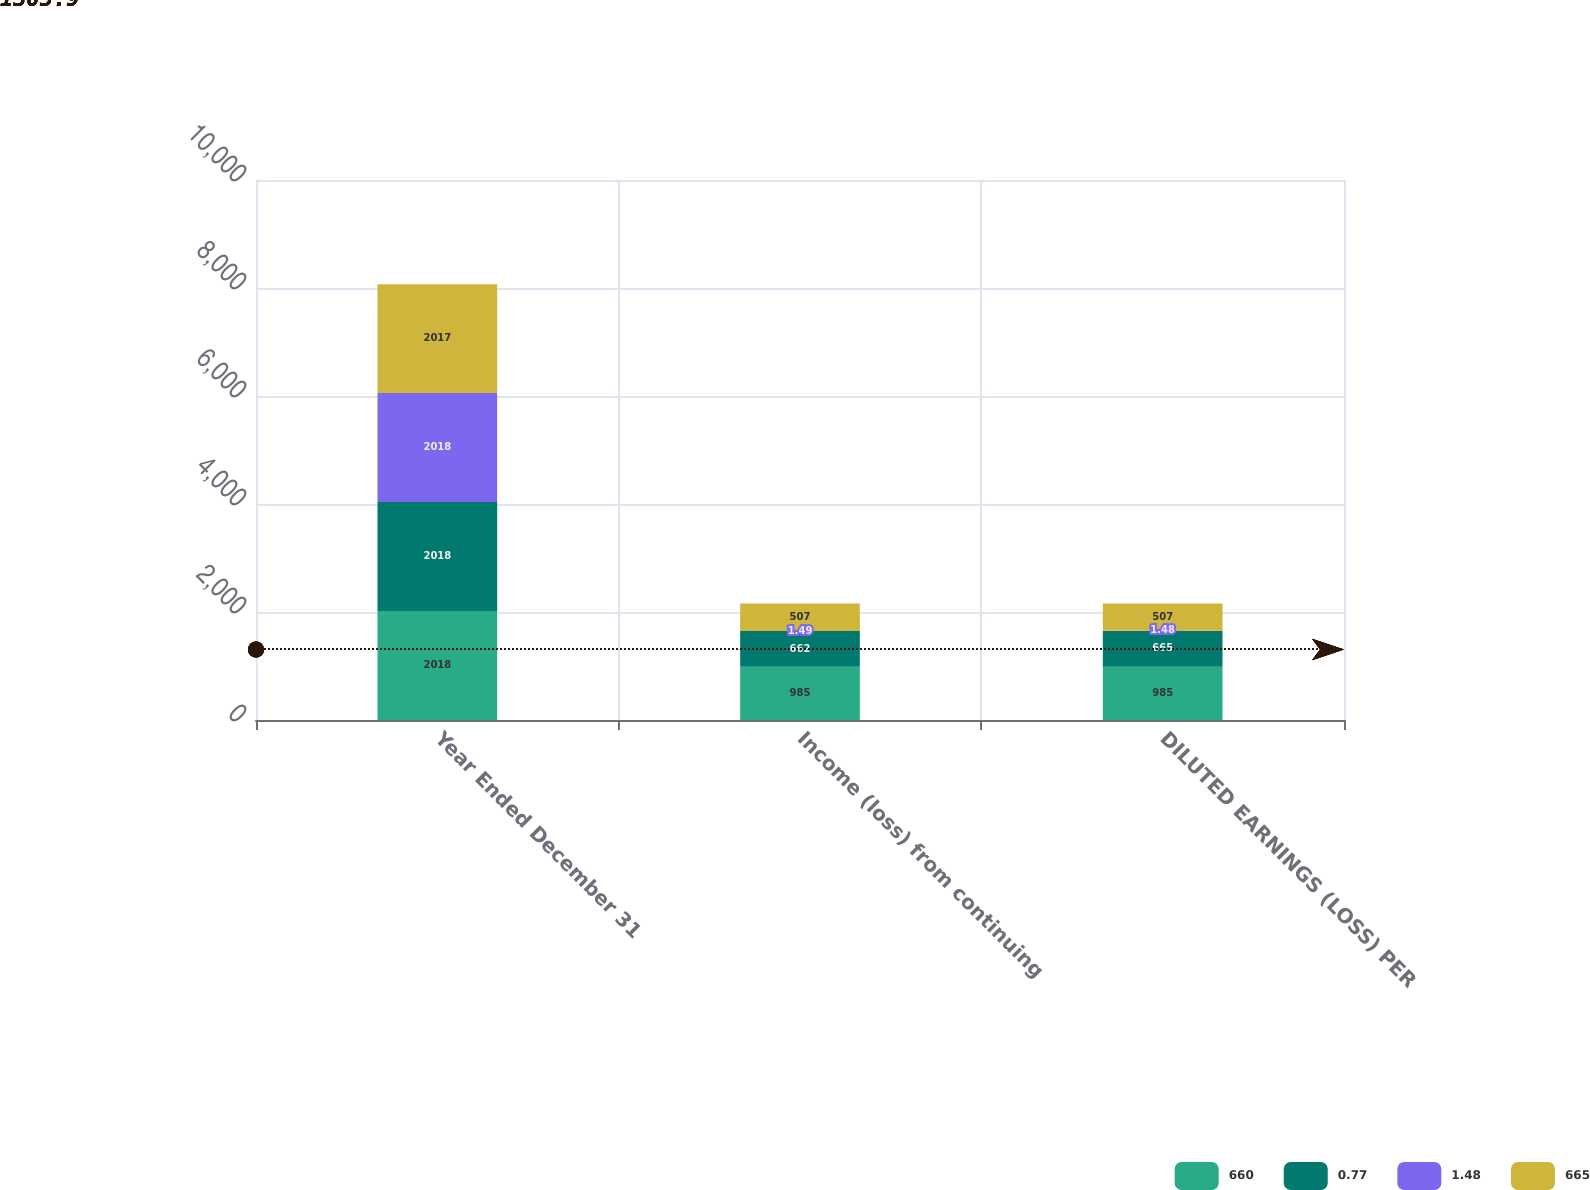Convert chart. <chart><loc_0><loc_0><loc_500><loc_500><stacked_bar_chart><ecel><fcel>Year Ended December 31<fcel>Income (loss) from continuing<fcel>DILUTED EARNINGS (LOSS) PER<nl><fcel>660<fcel>2018<fcel>985<fcel>985<nl><fcel>0.77<fcel>2018<fcel>662<fcel>665<nl><fcel>1.48<fcel>2018<fcel>1.49<fcel>1.48<nl><fcel>665<fcel>2017<fcel>507<fcel>507<nl></chart> 